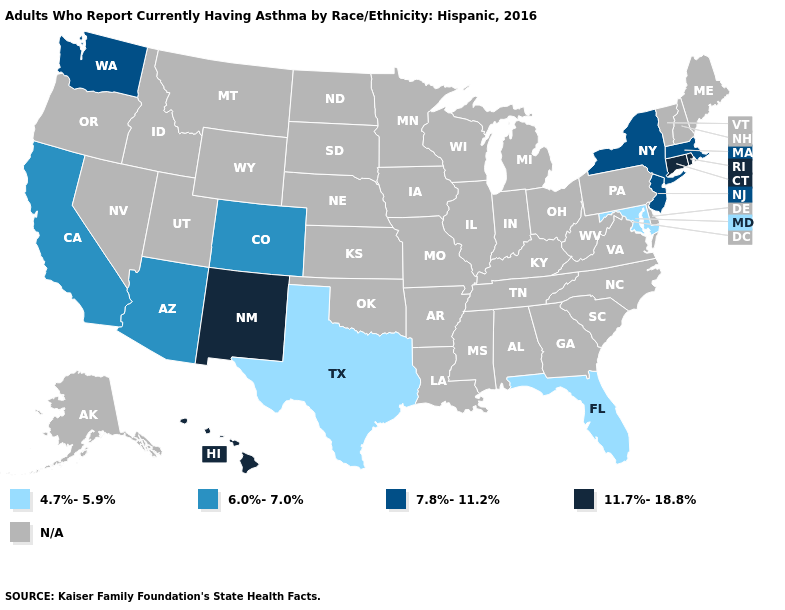What is the value of Montana?
Short answer required. N/A. What is the value of Wisconsin?
Concise answer only. N/A. What is the value of Mississippi?
Be succinct. N/A. Does Connecticut have the lowest value in the USA?
Keep it brief. No. Name the states that have a value in the range 7.8%-11.2%?
Give a very brief answer. Massachusetts, New Jersey, New York, Washington. Which states have the lowest value in the USA?
Be succinct. Florida, Maryland, Texas. What is the value of New Mexico?
Quick response, please. 11.7%-18.8%. What is the value of Michigan?
Quick response, please. N/A. What is the value of Ohio?
Concise answer only. N/A. What is the highest value in the West ?
Answer briefly. 11.7%-18.8%. What is the value of Massachusetts?
Short answer required. 7.8%-11.2%. Does Rhode Island have the highest value in the USA?
Concise answer only. Yes. Name the states that have a value in the range N/A?
Keep it brief. Alabama, Alaska, Arkansas, Delaware, Georgia, Idaho, Illinois, Indiana, Iowa, Kansas, Kentucky, Louisiana, Maine, Michigan, Minnesota, Mississippi, Missouri, Montana, Nebraska, Nevada, New Hampshire, North Carolina, North Dakota, Ohio, Oklahoma, Oregon, Pennsylvania, South Carolina, South Dakota, Tennessee, Utah, Vermont, Virginia, West Virginia, Wisconsin, Wyoming. What is the highest value in the USA?
Quick response, please. 11.7%-18.8%. 